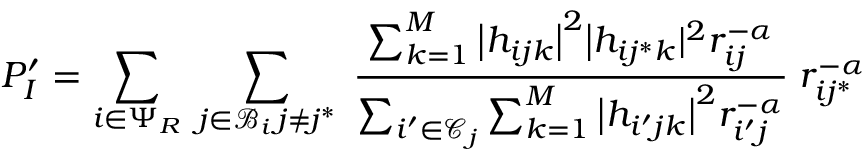<formula> <loc_0><loc_0><loc_500><loc_500>P _ { I } ^ { \prime } = \sum _ { i \in \Psi _ { R } } \, \sum _ { \substack { j \in \mathcal { B } _ { i } \, j \neq j ^ { * } } } \, \frac { \sum _ { k = 1 } ^ { M } \Big | h _ { i j k } \Big | ^ { 2 } \Big | h _ { i j ^ { * } k } | ^ { 2 } r _ { i j } ^ { - \alpha } } { \sum _ { i ^ { \prime } \in \mathcal { C } _ { j } } \sum _ { k = 1 } ^ { M } \Big | h _ { i ^ { \prime } j k } \Big | ^ { 2 } r _ { i ^ { \prime } j } ^ { - \alpha } } \, r _ { i j ^ { * } } ^ { - \alpha }</formula> 